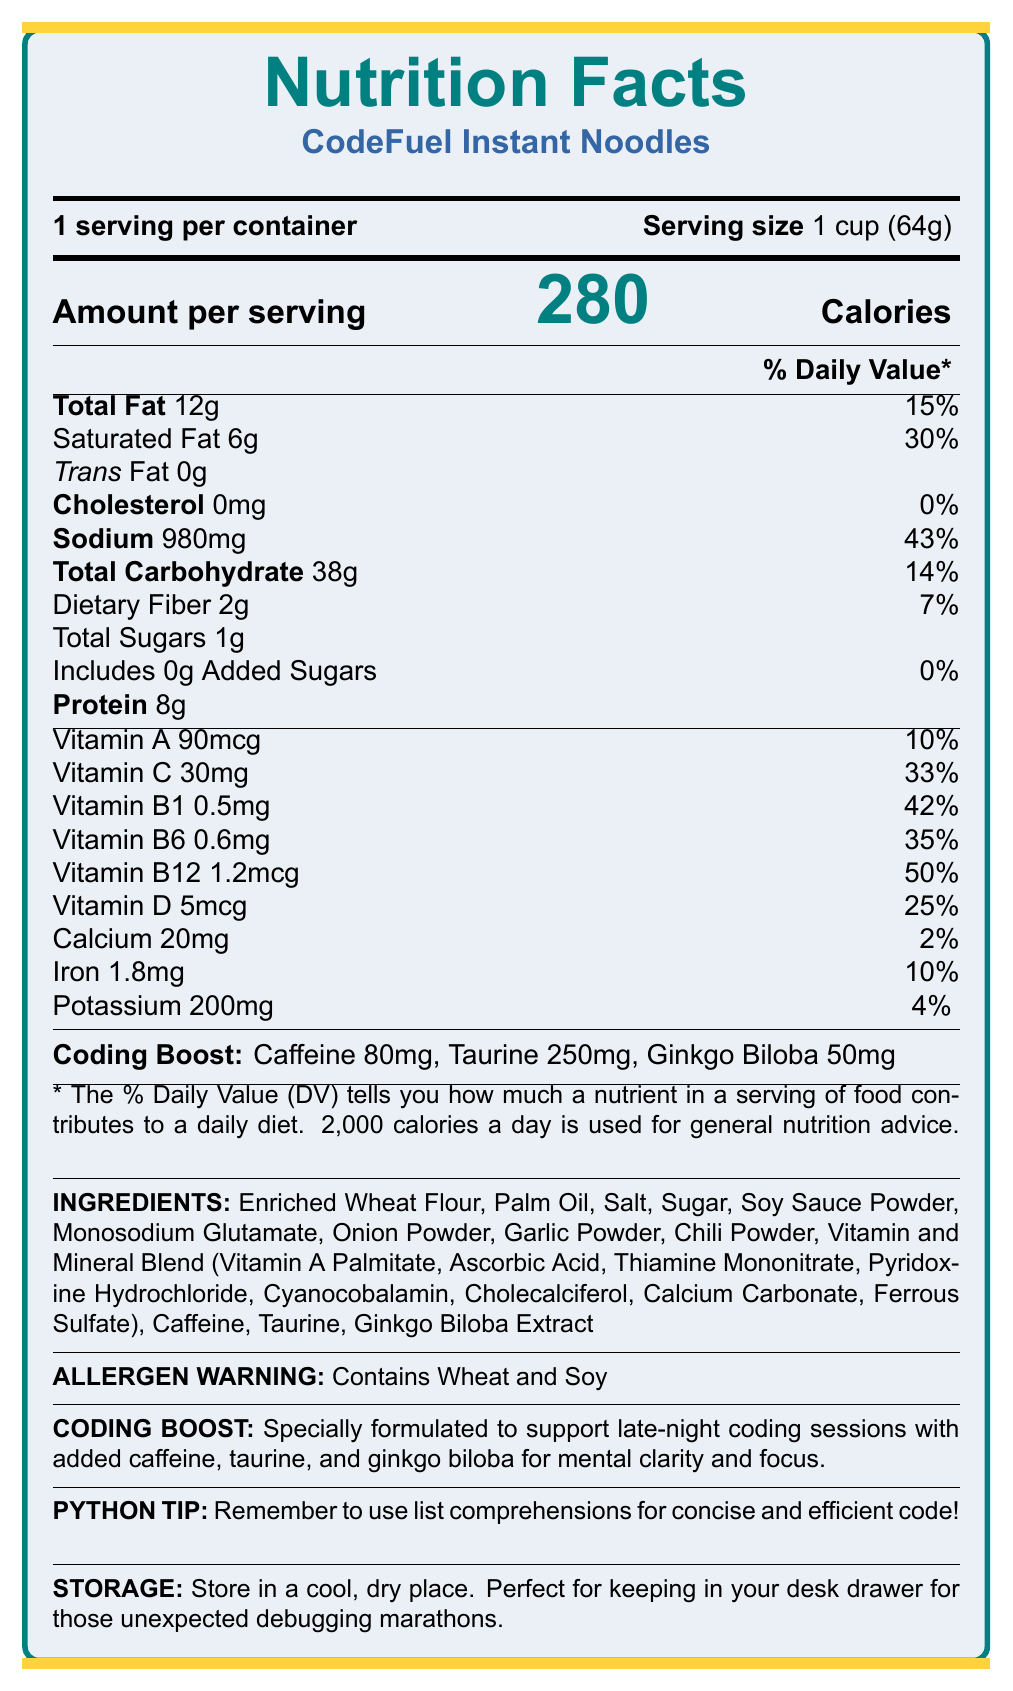what is the serving size of CodeFuel Instant Noodles? The serving size listed in the document is "1 cup (64g)".
Answer: 1 cup (64g) how many calories are in one serving? The document states that there are 280 calories per serving.
Answer: 280 how much sodium is in one serving? The sodium content per serving is indicated as 980mg.
Answer: 980mg what is the total fat content per serving? The total fat content per serving is listed as 12g.
Answer: 12g list three ingredients found in CodeFuel Instant Noodles Some of the ingredients listed in the document include Enriched Wheat Flour, Palm Oil, and Salt.
Answer: Enriched Wheat Flour, Palm Oil, Salt how many daily value percentages of Vitamin C does one serving contain? The document states that one serving contains 33% of the daily value for Vitamin C.
Answer: 33% does the product contain any added sugars? The document shows that there are 0g of added sugars in each serving.
Answer: No how many grams of protein are in one serving? According to the document, there are 8 grams of protein per serving.
Answer: 8g which vitamin in CodeFuel Instant Noodles has the highest daily value percentage? 
A. Vitamin A B. Vitamin C C. Vitamin B12 D. Vitamin D The daily value percentages listed in the document show Vitamin B12 at 50%, which is the highest among the options provided.
Answer: C. Vitamin B12 what is the recommended storage condition for this product?
A. In the fridge B. In a cool, dry place C. In the freezer D. At room temperature The document specifies that the product should be stored in a cool, dry place.
Answer: B. In a cool, dry place does the product contain soy? The allergen warning in the document states that it contains wheat and soy.
Answer: Yes describe the main purpose of CodeFuel Instant Noodles as indicated by the document The document emphasizes the product's formulation to support late-night coding with specific ingredients geared towards mental clarity and focus.
Answer: CodeFuel Instant Noodles are designed to support late-night coding sessions with added caffeine, taurine, and ginkgo biloba for mental clarity and focus. how much caffeine does one serving contain? The document lists the caffeine content per serving as 80mg.
Answer: 80mg is there any information about gluten in the document? The document does not provide any information regarding the presence or absence of gluten. It only mentions that it contains wheat and soy.
Answer: No 